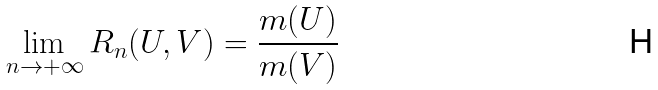Convert formula to latex. <formula><loc_0><loc_0><loc_500><loc_500>\lim _ { n \rightarrow + \infty } R _ { n } ( U , V ) = \frac { m ( U ) } { m ( V ) }</formula> 